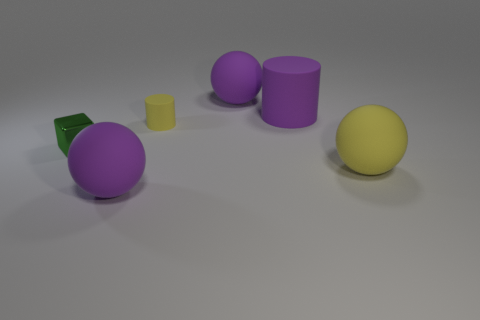Is there any other thing that has the same shape as the shiny thing?
Provide a succinct answer. No. What shape is the yellow thing that is made of the same material as the tiny yellow cylinder?
Provide a succinct answer. Sphere. Is the number of large objects that are behind the green metallic object greater than the number of objects behind the small yellow cylinder?
Provide a short and direct response. No. What number of objects are either green cubes or large cyan balls?
Offer a terse response. 1. How many other things are the same color as the tiny metal object?
Offer a very short reply. 0. What shape is the yellow object that is the same size as the purple rubber cylinder?
Your answer should be compact. Sphere. There is a small object behind the tiny metallic cube; what color is it?
Your answer should be compact. Yellow. What number of objects are objects that are behind the large cylinder or cylinders behind the small rubber cylinder?
Keep it short and to the point. 2. Do the green block and the yellow matte ball have the same size?
Provide a short and direct response. No. How many balls are either small objects or small blue things?
Your response must be concise. 0. 